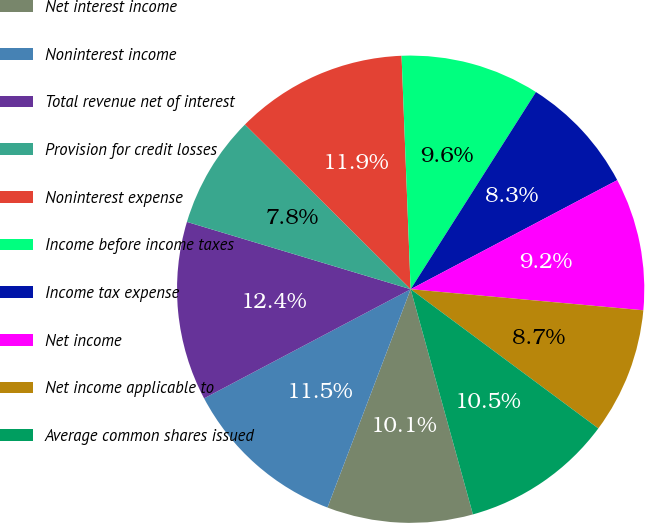Convert chart to OTSL. <chart><loc_0><loc_0><loc_500><loc_500><pie_chart><fcel>Net interest income<fcel>Noninterest income<fcel>Total revenue net of interest<fcel>Provision for credit losses<fcel>Noninterest expense<fcel>Income before income taxes<fcel>Income tax expense<fcel>Net income<fcel>Net income applicable to<fcel>Average common shares issued<nl><fcel>10.09%<fcel>11.47%<fcel>12.39%<fcel>7.8%<fcel>11.93%<fcel>9.63%<fcel>8.26%<fcel>9.17%<fcel>8.72%<fcel>10.55%<nl></chart> 